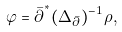<formula> <loc_0><loc_0><loc_500><loc_500>\varphi = \bar { \partial } ^ { ^ { * } } ( \Delta _ { \bar { \partial } } ) ^ { - 1 } \rho ,</formula> 